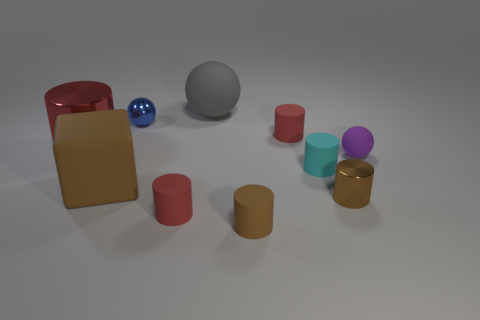What is the size of the rubber cylinder that is the same color as the big block?
Ensure brevity in your answer.  Small. What is the material of the object that is both right of the gray rubber ball and behind the purple matte sphere?
Your response must be concise. Rubber. There is a tiny cyan object that is the same material as the big cube; what shape is it?
Provide a short and direct response. Cylinder. Is there any other thing that has the same color as the large cube?
Your answer should be very brief. Yes. Are there more gray objects that are in front of the purple thing than blue spheres?
Keep it short and to the point. No. What is the big red cylinder made of?
Keep it short and to the point. Metal. What number of purple matte spheres have the same size as the cyan matte thing?
Give a very brief answer. 1. Are there the same number of tiny purple balls that are in front of the tiny brown matte cylinder and blue metal objects that are in front of the purple ball?
Give a very brief answer. Yes. Does the blue thing have the same material as the tiny purple sphere?
Provide a succinct answer. No. There is a large matte object that is behind the tiny blue shiny ball; is there a big brown thing right of it?
Provide a short and direct response. No. 